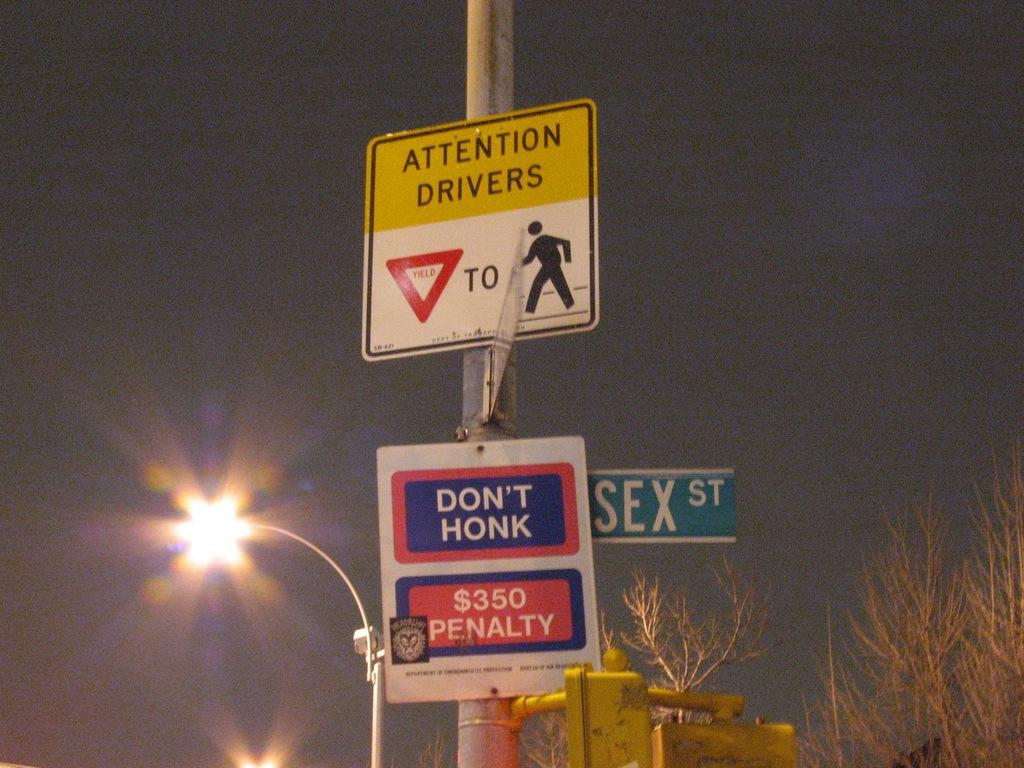<image>
Give a short and clear explanation of the subsequent image. Signs on a pole telling drivers to yield to pedestrians and not to honk, given a $350 penalty. 